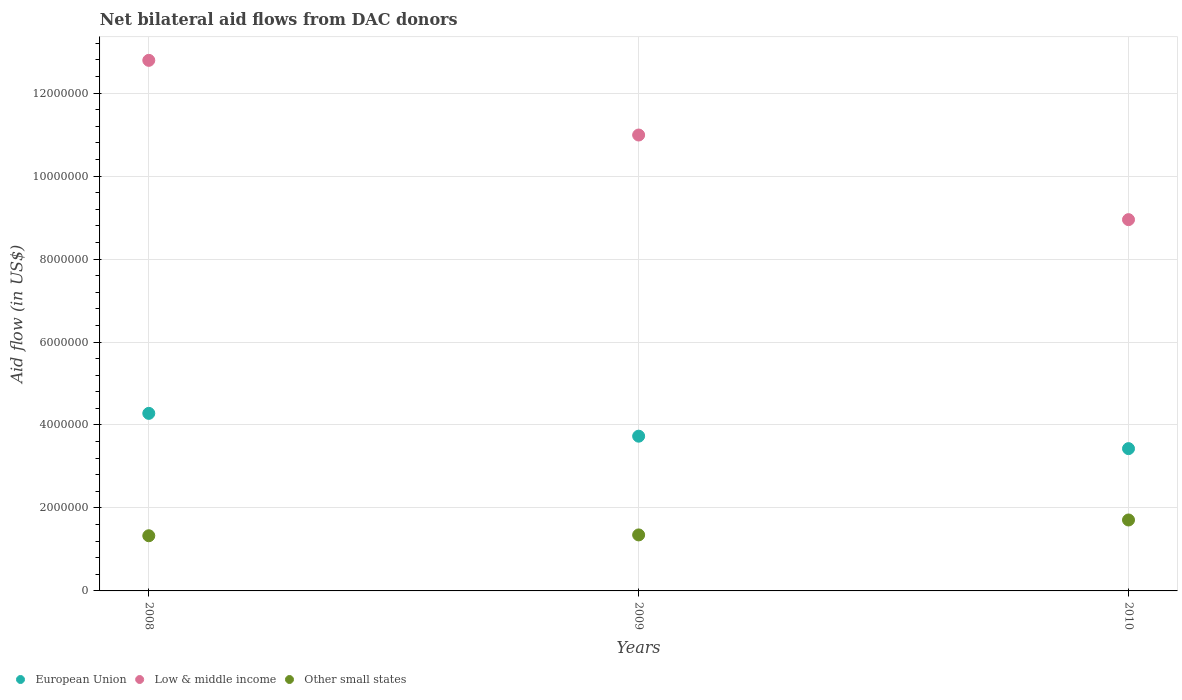What is the net bilateral aid flow in European Union in 2010?
Make the answer very short. 3.43e+06. Across all years, what is the maximum net bilateral aid flow in Other small states?
Provide a short and direct response. 1.71e+06. Across all years, what is the minimum net bilateral aid flow in European Union?
Your answer should be very brief. 3.43e+06. What is the total net bilateral aid flow in Other small states in the graph?
Provide a succinct answer. 4.39e+06. What is the difference between the net bilateral aid flow in European Union in 2008 and that in 2010?
Keep it short and to the point. 8.50e+05. What is the difference between the net bilateral aid flow in Other small states in 2008 and the net bilateral aid flow in European Union in 2010?
Your answer should be very brief. -2.10e+06. What is the average net bilateral aid flow in European Union per year?
Keep it short and to the point. 3.81e+06. In the year 2008, what is the difference between the net bilateral aid flow in Other small states and net bilateral aid flow in Low & middle income?
Your answer should be very brief. -1.15e+07. In how many years, is the net bilateral aid flow in Other small states greater than 6000000 US$?
Offer a terse response. 0. What is the ratio of the net bilateral aid flow in Low & middle income in 2008 to that in 2009?
Keep it short and to the point. 1.16. Is the difference between the net bilateral aid flow in Other small states in 2008 and 2009 greater than the difference between the net bilateral aid flow in Low & middle income in 2008 and 2009?
Ensure brevity in your answer.  No. What is the difference between the highest and the second highest net bilateral aid flow in Other small states?
Keep it short and to the point. 3.60e+05. What is the difference between the highest and the lowest net bilateral aid flow in Other small states?
Ensure brevity in your answer.  3.80e+05. Does the net bilateral aid flow in European Union monotonically increase over the years?
Offer a terse response. No. Is the net bilateral aid flow in Other small states strictly less than the net bilateral aid flow in European Union over the years?
Your answer should be compact. Yes. How many years are there in the graph?
Make the answer very short. 3. What is the difference between two consecutive major ticks on the Y-axis?
Your response must be concise. 2.00e+06. Does the graph contain any zero values?
Your answer should be very brief. No. What is the title of the graph?
Provide a succinct answer. Net bilateral aid flows from DAC donors. Does "Isle of Man" appear as one of the legend labels in the graph?
Offer a very short reply. No. What is the label or title of the X-axis?
Ensure brevity in your answer.  Years. What is the label or title of the Y-axis?
Your answer should be very brief. Aid flow (in US$). What is the Aid flow (in US$) of European Union in 2008?
Offer a terse response. 4.28e+06. What is the Aid flow (in US$) of Low & middle income in 2008?
Your response must be concise. 1.28e+07. What is the Aid flow (in US$) of Other small states in 2008?
Your answer should be compact. 1.33e+06. What is the Aid flow (in US$) of European Union in 2009?
Keep it short and to the point. 3.73e+06. What is the Aid flow (in US$) of Low & middle income in 2009?
Offer a very short reply. 1.10e+07. What is the Aid flow (in US$) in Other small states in 2009?
Give a very brief answer. 1.35e+06. What is the Aid flow (in US$) in European Union in 2010?
Give a very brief answer. 3.43e+06. What is the Aid flow (in US$) of Low & middle income in 2010?
Provide a short and direct response. 8.95e+06. What is the Aid flow (in US$) of Other small states in 2010?
Offer a terse response. 1.71e+06. Across all years, what is the maximum Aid flow (in US$) of European Union?
Your answer should be very brief. 4.28e+06. Across all years, what is the maximum Aid flow (in US$) in Low & middle income?
Give a very brief answer. 1.28e+07. Across all years, what is the maximum Aid flow (in US$) in Other small states?
Make the answer very short. 1.71e+06. Across all years, what is the minimum Aid flow (in US$) in European Union?
Your response must be concise. 3.43e+06. Across all years, what is the minimum Aid flow (in US$) in Low & middle income?
Offer a very short reply. 8.95e+06. Across all years, what is the minimum Aid flow (in US$) of Other small states?
Ensure brevity in your answer.  1.33e+06. What is the total Aid flow (in US$) of European Union in the graph?
Provide a short and direct response. 1.14e+07. What is the total Aid flow (in US$) of Low & middle income in the graph?
Ensure brevity in your answer.  3.27e+07. What is the total Aid flow (in US$) in Other small states in the graph?
Offer a terse response. 4.39e+06. What is the difference between the Aid flow (in US$) in European Union in 2008 and that in 2009?
Give a very brief answer. 5.50e+05. What is the difference between the Aid flow (in US$) in Low & middle income in 2008 and that in 2009?
Your answer should be compact. 1.80e+06. What is the difference between the Aid flow (in US$) of European Union in 2008 and that in 2010?
Provide a short and direct response. 8.50e+05. What is the difference between the Aid flow (in US$) of Low & middle income in 2008 and that in 2010?
Keep it short and to the point. 3.84e+06. What is the difference between the Aid flow (in US$) of Other small states in 2008 and that in 2010?
Provide a short and direct response. -3.80e+05. What is the difference between the Aid flow (in US$) of Low & middle income in 2009 and that in 2010?
Keep it short and to the point. 2.04e+06. What is the difference between the Aid flow (in US$) in Other small states in 2009 and that in 2010?
Your response must be concise. -3.60e+05. What is the difference between the Aid flow (in US$) in European Union in 2008 and the Aid flow (in US$) in Low & middle income in 2009?
Keep it short and to the point. -6.71e+06. What is the difference between the Aid flow (in US$) of European Union in 2008 and the Aid flow (in US$) of Other small states in 2009?
Provide a succinct answer. 2.93e+06. What is the difference between the Aid flow (in US$) in Low & middle income in 2008 and the Aid flow (in US$) in Other small states in 2009?
Ensure brevity in your answer.  1.14e+07. What is the difference between the Aid flow (in US$) of European Union in 2008 and the Aid flow (in US$) of Low & middle income in 2010?
Keep it short and to the point. -4.67e+06. What is the difference between the Aid flow (in US$) in European Union in 2008 and the Aid flow (in US$) in Other small states in 2010?
Your answer should be compact. 2.57e+06. What is the difference between the Aid flow (in US$) in Low & middle income in 2008 and the Aid flow (in US$) in Other small states in 2010?
Provide a succinct answer. 1.11e+07. What is the difference between the Aid flow (in US$) of European Union in 2009 and the Aid flow (in US$) of Low & middle income in 2010?
Make the answer very short. -5.22e+06. What is the difference between the Aid flow (in US$) of European Union in 2009 and the Aid flow (in US$) of Other small states in 2010?
Give a very brief answer. 2.02e+06. What is the difference between the Aid flow (in US$) in Low & middle income in 2009 and the Aid flow (in US$) in Other small states in 2010?
Your answer should be very brief. 9.28e+06. What is the average Aid flow (in US$) of European Union per year?
Ensure brevity in your answer.  3.81e+06. What is the average Aid flow (in US$) in Low & middle income per year?
Your response must be concise. 1.09e+07. What is the average Aid flow (in US$) of Other small states per year?
Provide a succinct answer. 1.46e+06. In the year 2008, what is the difference between the Aid flow (in US$) in European Union and Aid flow (in US$) in Low & middle income?
Offer a very short reply. -8.51e+06. In the year 2008, what is the difference between the Aid flow (in US$) of European Union and Aid flow (in US$) of Other small states?
Make the answer very short. 2.95e+06. In the year 2008, what is the difference between the Aid flow (in US$) in Low & middle income and Aid flow (in US$) in Other small states?
Ensure brevity in your answer.  1.15e+07. In the year 2009, what is the difference between the Aid flow (in US$) of European Union and Aid flow (in US$) of Low & middle income?
Your response must be concise. -7.26e+06. In the year 2009, what is the difference between the Aid flow (in US$) of European Union and Aid flow (in US$) of Other small states?
Offer a terse response. 2.38e+06. In the year 2009, what is the difference between the Aid flow (in US$) in Low & middle income and Aid flow (in US$) in Other small states?
Your response must be concise. 9.64e+06. In the year 2010, what is the difference between the Aid flow (in US$) of European Union and Aid flow (in US$) of Low & middle income?
Your answer should be very brief. -5.52e+06. In the year 2010, what is the difference between the Aid flow (in US$) of European Union and Aid flow (in US$) of Other small states?
Your answer should be compact. 1.72e+06. In the year 2010, what is the difference between the Aid flow (in US$) of Low & middle income and Aid flow (in US$) of Other small states?
Provide a short and direct response. 7.24e+06. What is the ratio of the Aid flow (in US$) of European Union in 2008 to that in 2009?
Offer a very short reply. 1.15. What is the ratio of the Aid flow (in US$) in Low & middle income in 2008 to that in 2009?
Offer a very short reply. 1.16. What is the ratio of the Aid flow (in US$) in Other small states in 2008 to that in 2009?
Keep it short and to the point. 0.99. What is the ratio of the Aid flow (in US$) in European Union in 2008 to that in 2010?
Provide a succinct answer. 1.25. What is the ratio of the Aid flow (in US$) of Low & middle income in 2008 to that in 2010?
Give a very brief answer. 1.43. What is the ratio of the Aid flow (in US$) of Other small states in 2008 to that in 2010?
Your answer should be compact. 0.78. What is the ratio of the Aid flow (in US$) in European Union in 2009 to that in 2010?
Ensure brevity in your answer.  1.09. What is the ratio of the Aid flow (in US$) of Low & middle income in 2009 to that in 2010?
Provide a succinct answer. 1.23. What is the ratio of the Aid flow (in US$) of Other small states in 2009 to that in 2010?
Offer a very short reply. 0.79. What is the difference between the highest and the second highest Aid flow (in US$) in European Union?
Make the answer very short. 5.50e+05. What is the difference between the highest and the second highest Aid flow (in US$) in Low & middle income?
Offer a very short reply. 1.80e+06. What is the difference between the highest and the second highest Aid flow (in US$) in Other small states?
Make the answer very short. 3.60e+05. What is the difference between the highest and the lowest Aid flow (in US$) of European Union?
Offer a very short reply. 8.50e+05. What is the difference between the highest and the lowest Aid flow (in US$) of Low & middle income?
Ensure brevity in your answer.  3.84e+06. What is the difference between the highest and the lowest Aid flow (in US$) in Other small states?
Offer a very short reply. 3.80e+05. 